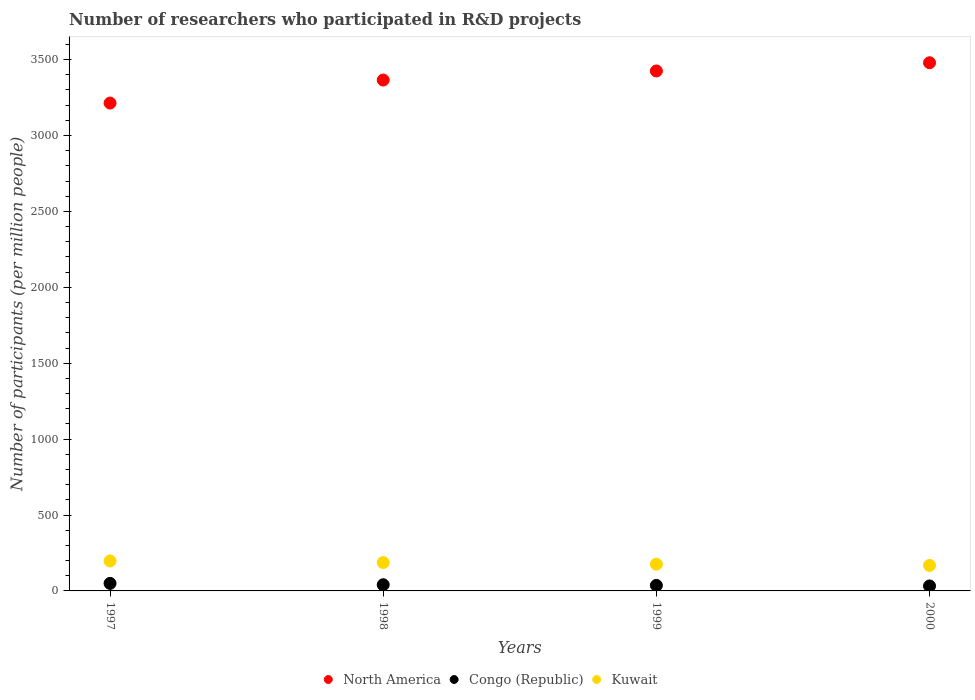Is the number of dotlines equal to the number of legend labels?
Your answer should be compact. Yes. What is the number of researchers who participated in R&D projects in North America in 1998?
Ensure brevity in your answer.  3365.33. Across all years, what is the maximum number of researchers who participated in R&D projects in North America?
Your answer should be very brief. 3479.34. Across all years, what is the minimum number of researchers who participated in R&D projects in Congo (Republic)?
Your answer should be very brief. 32.72. In which year was the number of researchers who participated in R&D projects in Kuwait minimum?
Your answer should be very brief. 2000. What is the total number of researchers who participated in R&D projects in Congo (Republic) in the graph?
Ensure brevity in your answer.  159.4. What is the difference between the number of researchers who participated in R&D projects in Kuwait in 1999 and that in 2000?
Your answer should be compact. 7.99. What is the difference between the number of researchers who participated in R&D projects in Congo (Republic) in 1998 and the number of researchers who participated in R&D projects in Kuwait in 1999?
Provide a short and direct response. -135.2. What is the average number of researchers who participated in R&D projects in North America per year?
Your answer should be very brief. 3370.88. In the year 1999, what is the difference between the number of researchers who participated in R&D projects in Congo (Republic) and number of researchers who participated in R&D projects in North America?
Keep it short and to the point. -3388.81. In how many years, is the number of researchers who participated in R&D projects in Congo (Republic) greater than 300?
Make the answer very short. 0. What is the ratio of the number of researchers who participated in R&D projects in Congo (Republic) in 1997 to that in 1999?
Provide a succinct answer. 1.36. What is the difference between the highest and the second highest number of researchers who participated in R&D projects in North America?
Make the answer very short. 54.17. What is the difference between the highest and the lowest number of researchers who participated in R&D projects in Kuwait?
Offer a terse response. 29.56. In how many years, is the number of researchers who participated in R&D projects in Congo (Republic) greater than the average number of researchers who participated in R&D projects in Congo (Republic) taken over all years?
Offer a terse response. 2. Does the number of researchers who participated in R&D projects in Kuwait monotonically increase over the years?
Your answer should be compact. No. Is the number of researchers who participated in R&D projects in Kuwait strictly greater than the number of researchers who participated in R&D projects in Congo (Republic) over the years?
Provide a short and direct response. Yes. How many years are there in the graph?
Provide a short and direct response. 4. Where does the legend appear in the graph?
Offer a terse response. Bottom center. How many legend labels are there?
Offer a terse response. 3. What is the title of the graph?
Make the answer very short. Number of researchers who participated in R&D projects. Does "China" appear as one of the legend labels in the graph?
Provide a short and direct response. No. What is the label or title of the Y-axis?
Give a very brief answer. Number of participants (per million people). What is the Number of participants (per million people) of North America in 1997?
Offer a terse response. 3213.68. What is the Number of participants (per million people) of Congo (Republic) in 1997?
Offer a very short reply. 49.59. What is the Number of participants (per million people) of Kuwait in 1997?
Provide a succinct answer. 197.48. What is the Number of participants (per million people) in North America in 1998?
Provide a short and direct response. 3365.33. What is the Number of participants (per million people) of Congo (Republic) in 1998?
Ensure brevity in your answer.  40.72. What is the Number of participants (per million people) of Kuwait in 1998?
Provide a succinct answer. 186.84. What is the Number of participants (per million people) of North America in 1999?
Provide a succinct answer. 3425.18. What is the Number of participants (per million people) of Congo (Republic) in 1999?
Keep it short and to the point. 36.36. What is the Number of participants (per million people) in Kuwait in 1999?
Offer a very short reply. 175.92. What is the Number of participants (per million people) in North America in 2000?
Make the answer very short. 3479.34. What is the Number of participants (per million people) of Congo (Republic) in 2000?
Offer a very short reply. 32.72. What is the Number of participants (per million people) of Kuwait in 2000?
Provide a succinct answer. 167.92. Across all years, what is the maximum Number of participants (per million people) of North America?
Provide a short and direct response. 3479.34. Across all years, what is the maximum Number of participants (per million people) in Congo (Republic)?
Your answer should be compact. 49.59. Across all years, what is the maximum Number of participants (per million people) of Kuwait?
Give a very brief answer. 197.48. Across all years, what is the minimum Number of participants (per million people) in North America?
Offer a terse response. 3213.68. Across all years, what is the minimum Number of participants (per million people) of Congo (Republic)?
Your answer should be compact. 32.72. Across all years, what is the minimum Number of participants (per million people) of Kuwait?
Your response must be concise. 167.92. What is the total Number of participants (per million people) of North America in the graph?
Your answer should be very brief. 1.35e+04. What is the total Number of participants (per million people) of Congo (Republic) in the graph?
Offer a terse response. 159.4. What is the total Number of participants (per million people) in Kuwait in the graph?
Keep it short and to the point. 728.15. What is the difference between the Number of participants (per million people) in North America in 1997 and that in 1998?
Keep it short and to the point. -151.65. What is the difference between the Number of participants (per million people) of Congo (Republic) in 1997 and that in 1998?
Your response must be concise. 8.87. What is the difference between the Number of participants (per million people) in Kuwait in 1997 and that in 1998?
Offer a very short reply. 10.64. What is the difference between the Number of participants (per million people) in North America in 1997 and that in 1999?
Give a very brief answer. -211.49. What is the difference between the Number of participants (per million people) in Congo (Republic) in 1997 and that in 1999?
Ensure brevity in your answer.  13.23. What is the difference between the Number of participants (per million people) of Kuwait in 1997 and that in 1999?
Your response must be concise. 21.56. What is the difference between the Number of participants (per million people) in North America in 1997 and that in 2000?
Offer a terse response. -265.66. What is the difference between the Number of participants (per million people) in Congo (Republic) in 1997 and that in 2000?
Provide a succinct answer. 16.86. What is the difference between the Number of participants (per million people) of Kuwait in 1997 and that in 2000?
Your answer should be very brief. 29.56. What is the difference between the Number of participants (per million people) in North America in 1998 and that in 1999?
Your answer should be very brief. -59.84. What is the difference between the Number of participants (per million people) of Congo (Republic) in 1998 and that in 1999?
Your answer should be very brief. 4.36. What is the difference between the Number of participants (per million people) in Kuwait in 1998 and that in 1999?
Offer a terse response. 10.92. What is the difference between the Number of participants (per million people) in North America in 1998 and that in 2000?
Keep it short and to the point. -114.01. What is the difference between the Number of participants (per million people) in Congo (Republic) in 1998 and that in 2000?
Keep it short and to the point. 8. What is the difference between the Number of participants (per million people) of Kuwait in 1998 and that in 2000?
Give a very brief answer. 18.92. What is the difference between the Number of participants (per million people) of North America in 1999 and that in 2000?
Provide a short and direct response. -54.17. What is the difference between the Number of participants (per million people) of Congo (Republic) in 1999 and that in 2000?
Give a very brief answer. 3.64. What is the difference between the Number of participants (per million people) in Kuwait in 1999 and that in 2000?
Your answer should be very brief. 7.99. What is the difference between the Number of participants (per million people) of North America in 1997 and the Number of participants (per million people) of Congo (Republic) in 1998?
Provide a succinct answer. 3172.96. What is the difference between the Number of participants (per million people) of North America in 1997 and the Number of participants (per million people) of Kuwait in 1998?
Provide a succinct answer. 3026.85. What is the difference between the Number of participants (per million people) of Congo (Republic) in 1997 and the Number of participants (per million people) of Kuwait in 1998?
Provide a short and direct response. -137.25. What is the difference between the Number of participants (per million people) of North America in 1997 and the Number of participants (per million people) of Congo (Republic) in 1999?
Offer a terse response. 3177.32. What is the difference between the Number of participants (per million people) in North America in 1997 and the Number of participants (per million people) in Kuwait in 1999?
Your answer should be very brief. 3037.77. What is the difference between the Number of participants (per million people) of Congo (Republic) in 1997 and the Number of participants (per million people) of Kuwait in 1999?
Give a very brief answer. -126.33. What is the difference between the Number of participants (per million people) of North America in 1997 and the Number of participants (per million people) of Congo (Republic) in 2000?
Make the answer very short. 3180.96. What is the difference between the Number of participants (per million people) of North America in 1997 and the Number of participants (per million people) of Kuwait in 2000?
Keep it short and to the point. 3045.76. What is the difference between the Number of participants (per million people) in Congo (Republic) in 1997 and the Number of participants (per million people) in Kuwait in 2000?
Give a very brief answer. -118.33. What is the difference between the Number of participants (per million people) in North America in 1998 and the Number of participants (per million people) in Congo (Republic) in 1999?
Keep it short and to the point. 3328.97. What is the difference between the Number of participants (per million people) in North America in 1998 and the Number of participants (per million people) in Kuwait in 1999?
Provide a succinct answer. 3189.41. What is the difference between the Number of participants (per million people) of Congo (Republic) in 1998 and the Number of participants (per million people) of Kuwait in 1999?
Your answer should be very brief. -135.2. What is the difference between the Number of participants (per million people) of North America in 1998 and the Number of participants (per million people) of Congo (Republic) in 2000?
Make the answer very short. 3332.61. What is the difference between the Number of participants (per million people) of North America in 1998 and the Number of participants (per million people) of Kuwait in 2000?
Give a very brief answer. 3197.41. What is the difference between the Number of participants (per million people) in Congo (Republic) in 1998 and the Number of participants (per million people) in Kuwait in 2000?
Give a very brief answer. -127.2. What is the difference between the Number of participants (per million people) of North America in 1999 and the Number of participants (per million people) of Congo (Republic) in 2000?
Offer a very short reply. 3392.45. What is the difference between the Number of participants (per million people) of North America in 1999 and the Number of participants (per million people) of Kuwait in 2000?
Provide a succinct answer. 3257.25. What is the difference between the Number of participants (per million people) of Congo (Republic) in 1999 and the Number of participants (per million people) of Kuwait in 2000?
Keep it short and to the point. -131.56. What is the average Number of participants (per million people) in North America per year?
Provide a succinct answer. 3370.88. What is the average Number of participants (per million people) in Congo (Republic) per year?
Provide a succinct answer. 39.85. What is the average Number of participants (per million people) in Kuwait per year?
Offer a terse response. 182.04. In the year 1997, what is the difference between the Number of participants (per million people) in North America and Number of participants (per million people) in Congo (Republic)?
Offer a terse response. 3164.09. In the year 1997, what is the difference between the Number of participants (per million people) of North America and Number of participants (per million people) of Kuwait?
Give a very brief answer. 3016.2. In the year 1997, what is the difference between the Number of participants (per million people) in Congo (Republic) and Number of participants (per million people) in Kuwait?
Provide a short and direct response. -147.89. In the year 1998, what is the difference between the Number of participants (per million people) in North America and Number of participants (per million people) in Congo (Republic)?
Offer a very short reply. 3324.61. In the year 1998, what is the difference between the Number of participants (per million people) in North America and Number of participants (per million people) in Kuwait?
Your answer should be compact. 3178.49. In the year 1998, what is the difference between the Number of participants (per million people) in Congo (Republic) and Number of participants (per million people) in Kuwait?
Your response must be concise. -146.12. In the year 1999, what is the difference between the Number of participants (per million people) of North America and Number of participants (per million people) of Congo (Republic)?
Provide a short and direct response. 3388.81. In the year 1999, what is the difference between the Number of participants (per million people) of North America and Number of participants (per million people) of Kuwait?
Provide a short and direct response. 3249.26. In the year 1999, what is the difference between the Number of participants (per million people) in Congo (Republic) and Number of participants (per million people) in Kuwait?
Provide a short and direct response. -139.55. In the year 2000, what is the difference between the Number of participants (per million people) in North America and Number of participants (per million people) in Congo (Republic)?
Provide a succinct answer. 3446.62. In the year 2000, what is the difference between the Number of participants (per million people) in North America and Number of participants (per million people) in Kuwait?
Make the answer very short. 3311.42. In the year 2000, what is the difference between the Number of participants (per million people) of Congo (Republic) and Number of participants (per million people) of Kuwait?
Your answer should be compact. -135.2. What is the ratio of the Number of participants (per million people) of North America in 1997 to that in 1998?
Your answer should be very brief. 0.95. What is the ratio of the Number of participants (per million people) of Congo (Republic) in 1997 to that in 1998?
Provide a short and direct response. 1.22. What is the ratio of the Number of participants (per million people) in Kuwait in 1997 to that in 1998?
Offer a terse response. 1.06. What is the ratio of the Number of participants (per million people) in North America in 1997 to that in 1999?
Provide a short and direct response. 0.94. What is the ratio of the Number of participants (per million people) in Congo (Republic) in 1997 to that in 1999?
Offer a terse response. 1.36. What is the ratio of the Number of participants (per million people) in Kuwait in 1997 to that in 1999?
Make the answer very short. 1.12. What is the ratio of the Number of participants (per million people) of North America in 1997 to that in 2000?
Give a very brief answer. 0.92. What is the ratio of the Number of participants (per million people) in Congo (Republic) in 1997 to that in 2000?
Offer a terse response. 1.52. What is the ratio of the Number of participants (per million people) in Kuwait in 1997 to that in 2000?
Make the answer very short. 1.18. What is the ratio of the Number of participants (per million people) of North America in 1998 to that in 1999?
Keep it short and to the point. 0.98. What is the ratio of the Number of participants (per million people) in Congo (Republic) in 1998 to that in 1999?
Keep it short and to the point. 1.12. What is the ratio of the Number of participants (per million people) of Kuwait in 1998 to that in 1999?
Provide a short and direct response. 1.06. What is the ratio of the Number of participants (per million people) of North America in 1998 to that in 2000?
Provide a succinct answer. 0.97. What is the ratio of the Number of participants (per million people) of Congo (Republic) in 1998 to that in 2000?
Your response must be concise. 1.24. What is the ratio of the Number of participants (per million people) in Kuwait in 1998 to that in 2000?
Provide a short and direct response. 1.11. What is the ratio of the Number of participants (per million people) in North America in 1999 to that in 2000?
Give a very brief answer. 0.98. What is the ratio of the Number of participants (per million people) of Congo (Republic) in 1999 to that in 2000?
Your answer should be compact. 1.11. What is the ratio of the Number of participants (per million people) of Kuwait in 1999 to that in 2000?
Keep it short and to the point. 1.05. What is the difference between the highest and the second highest Number of participants (per million people) of North America?
Provide a short and direct response. 54.17. What is the difference between the highest and the second highest Number of participants (per million people) in Congo (Republic)?
Your answer should be compact. 8.87. What is the difference between the highest and the second highest Number of participants (per million people) in Kuwait?
Your response must be concise. 10.64. What is the difference between the highest and the lowest Number of participants (per million people) in North America?
Offer a very short reply. 265.66. What is the difference between the highest and the lowest Number of participants (per million people) in Congo (Republic)?
Provide a short and direct response. 16.86. What is the difference between the highest and the lowest Number of participants (per million people) of Kuwait?
Provide a succinct answer. 29.56. 